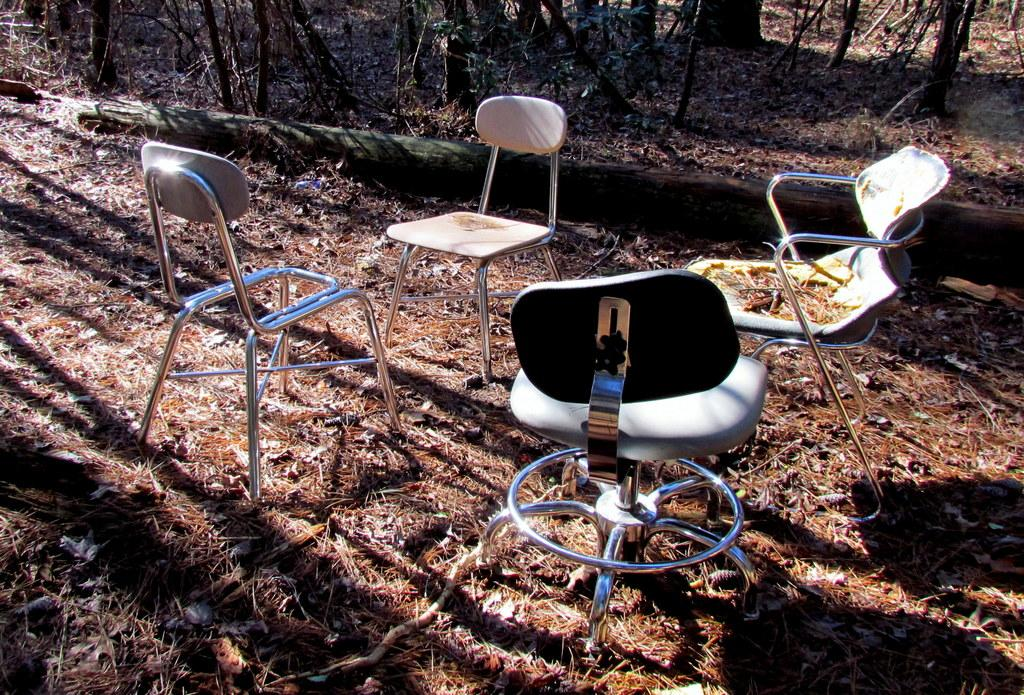How many chairs are visible in the image? There are four chairs on the ground in the image. What can be seen in the background of the image? There is a tree trunk and trees in the background of the image. Can you determine the time of day when the image was taken? The image was likely taken during the day, as there is sufficient light to see the chairs and background clearly. What color is the crayon used to draw the alarm in the image? There is no crayon or drawing of an alarm present in the image. 